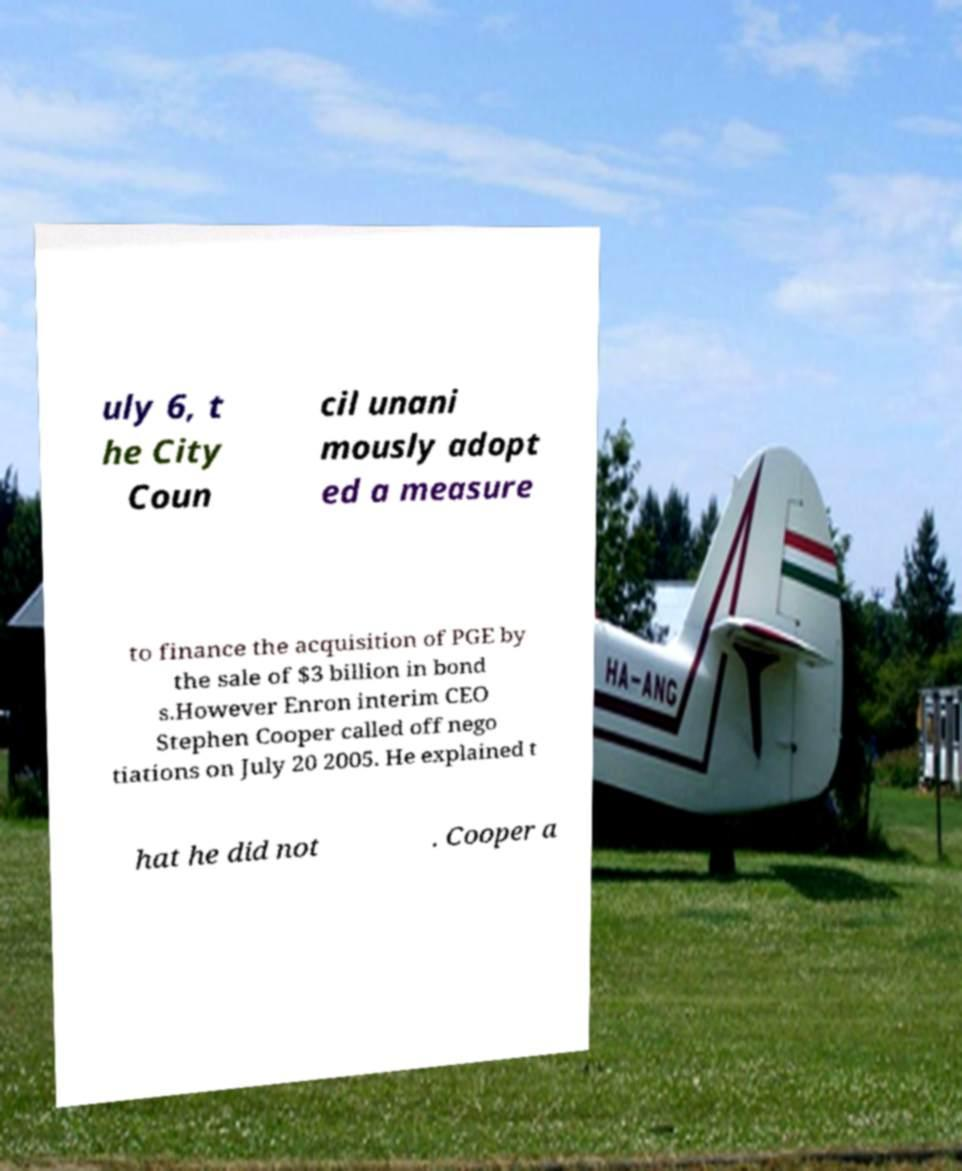Can you accurately transcribe the text from the provided image for me? uly 6, t he City Coun cil unani mously adopt ed a measure to finance the acquisition of PGE by the sale of $3 billion in bond s.However Enron interim CEO Stephen Cooper called off nego tiations on July 20 2005. He explained t hat he did not . Cooper a 